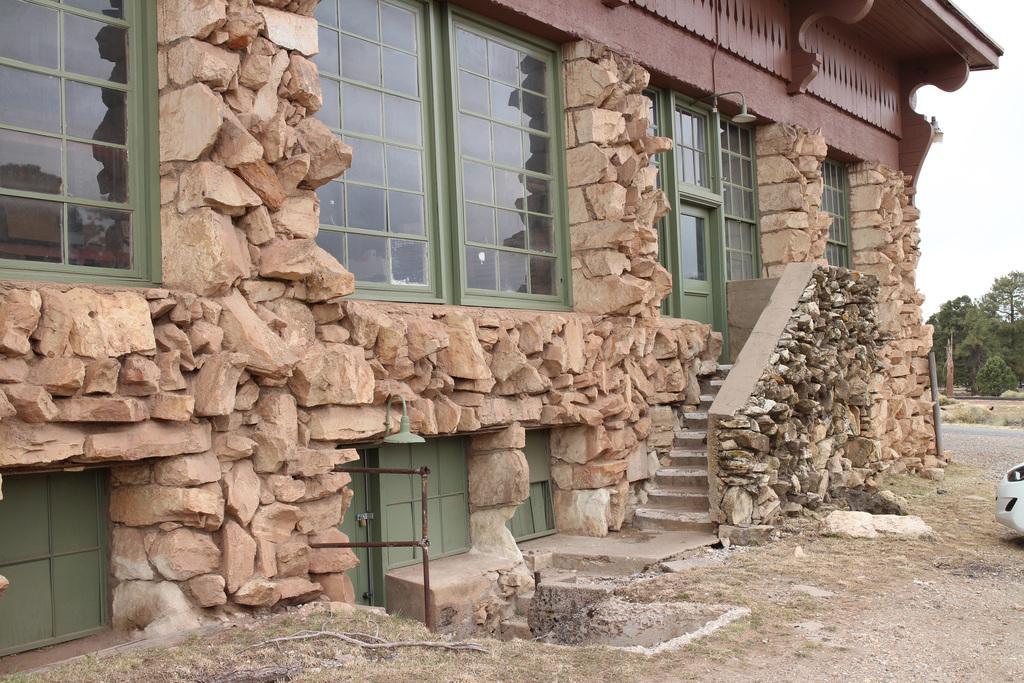How would you summarize this image in a sentence or two? In this image we can see a building with windows. We can also see the rocks, metal poles, a vehicle on the ground, a group of trees and the sky. 